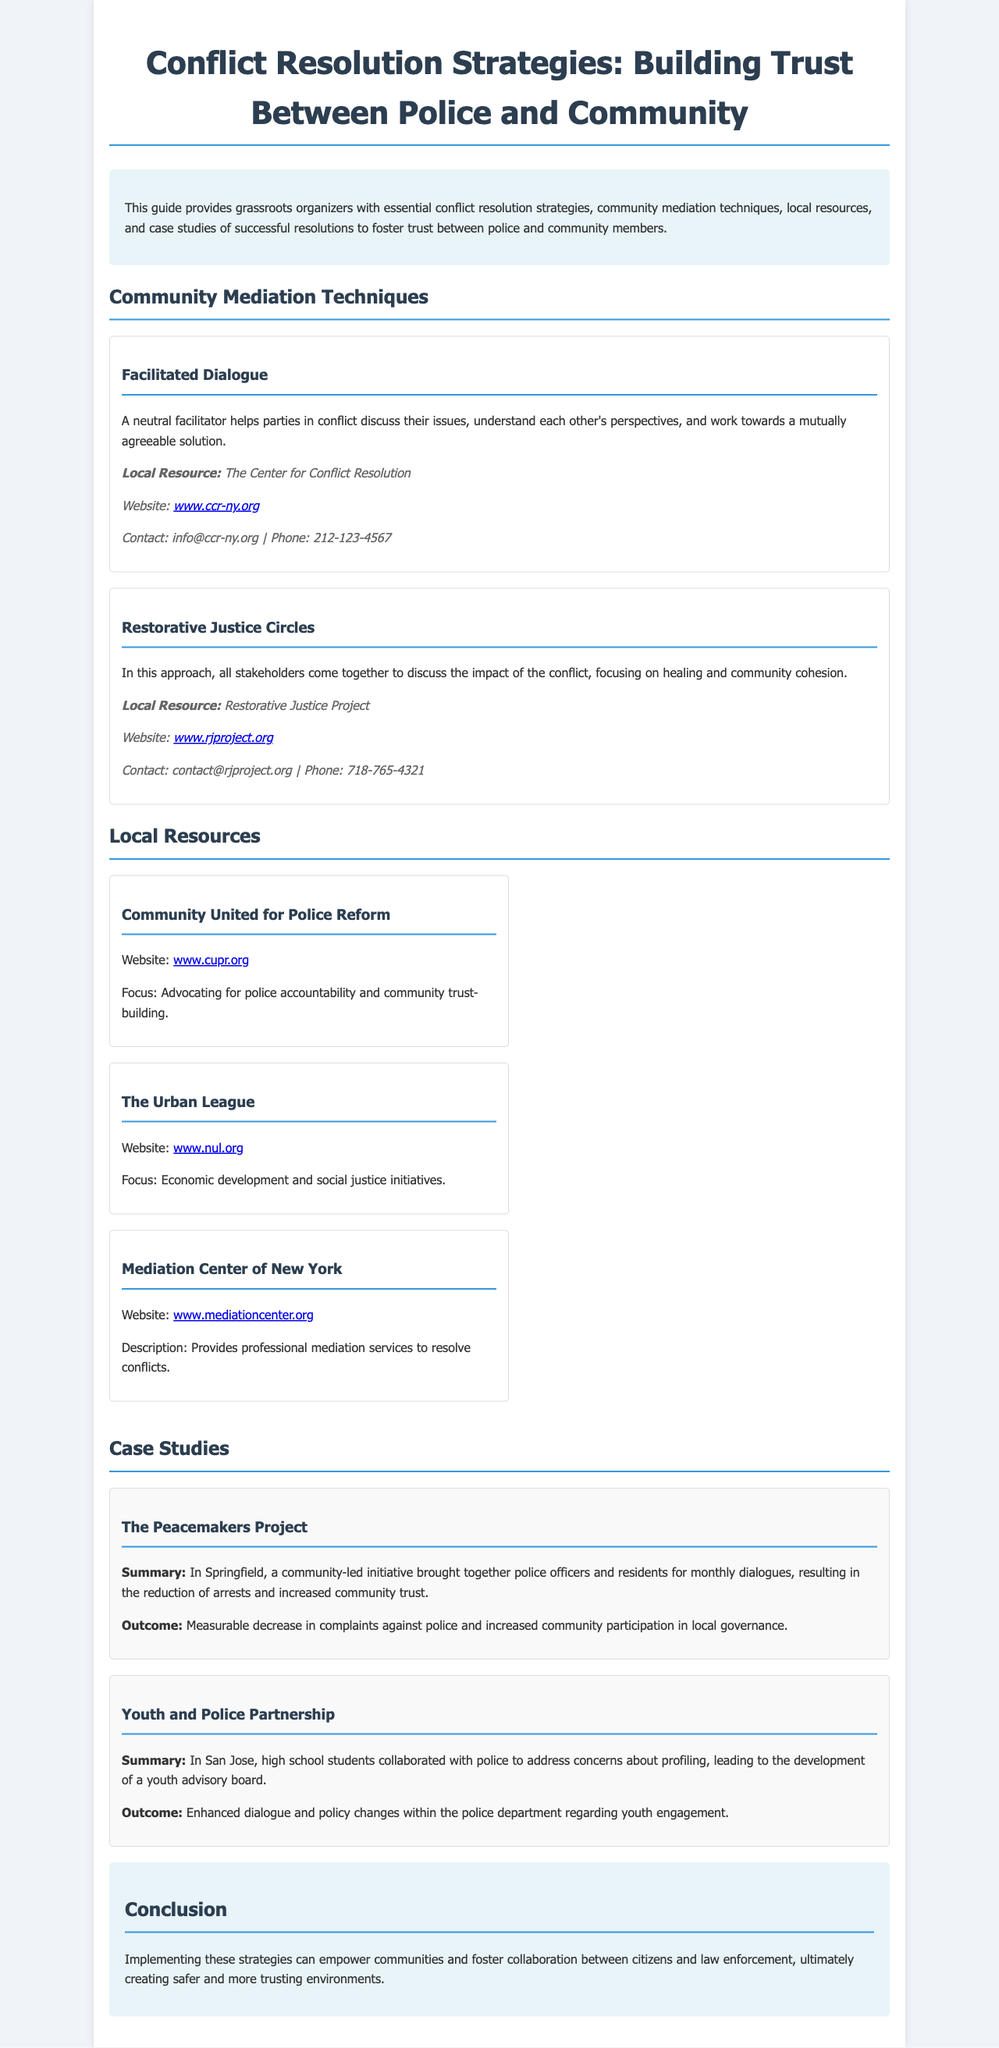what is the title of the manual? The title of the manual is displayed prominently at the top of the document.
Answer: Conflict Resolution Strategies: Building Trust Between Police and Community who provides the contact information for the Restorative Justice Circles technique? The document lists the local resource contact information following the description of the technique.
Answer: Restorative Justice Project how many case studies are included in the manual? The manual presents two distinct case studies in the designated section.
Answer: 2 what is the contact email for the Center for Conflict Resolution? The contact email is provided under the local resource section for the first community mediation technique.
Answer: info@ccr-ny.org what is the focus of the Community United for Police Reform? The focus is stated clearly in the details provided for the local resource.
Answer: Advocating for police accountability and community trust-building what outcome did The Peacemakers Project achieve? The outcome is summarized in the case study section detailing the results of the initiative.
Answer: Measurable decrease in complaints against police and increased community participation in local governance which technique involves discussing the impact of the conflict? The specific technique is highlighted in the community mediation techniques section.
Answer: Restorative Justice Circles what is the website for the Mediation Center of New York? The website is mentioned in the local resources section under the respective resource description.
Answer: www.mediationcenter.org 